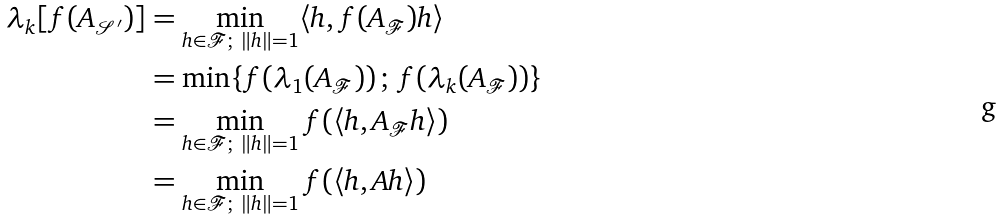Convert formula to latex. <formula><loc_0><loc_0><loc_500><loc_500>\lambda _ { k } [ f ( A _ { \mathcal { S ^ { \prime } } } ) ] & = \min _ { h \in { \mathcal { F } } ; \ \| h \| = 1 } \langle h , f ( A _ { \mathcal { F } } ) h \rangle \\ & = \min \{ f ( \lambda _ { 1 } ( A _ { \mathcal { F } } ) ) \, ; \, f ( \lambda _ { k } ( A _ { \mathcal { F } } ) ) \} \\ & = \min _ { h \in { \mathcal { F } } ; \ \| h \| = 1 } f ( \langle h , A _ { \mathcal { F } } h \rangle ) \\ & = \min _ { h \in { \mathcal { F } } ; \ \| h \| = 1 } f ( \langle h , A h \rangle )</formula> 